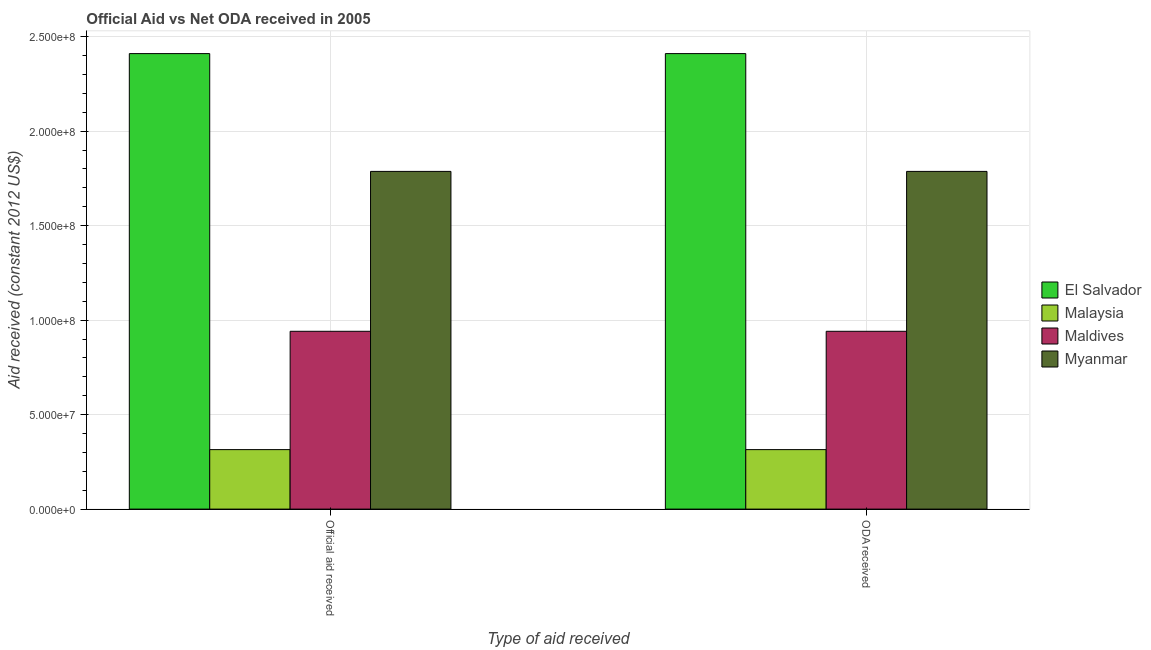How many different coloured bars are there?
Offer a terse response. 4. How many bars are there on the 2nd tick from the right?
Your response must be concise. 4. What is the label of the 1st group of bars from the left?
Make the answer very short. Official aid received. What is the official aid received in Malaysia?
Make the answer very short. 3.15e+07. Across all countries, what is the maximum oda received?
Your answer should be very brief. 2.41e+08. Across all countries, what is the minimum oda received?
Provide a short and direct response. 3.15e+07. In which country was the oda received maximum?
Ensure brevity in your answer.  El Salvador. In which country was the oda received minimum?
Your answer should be very brief. Malaysia. What is the total oda received in the graph?
Keep it short and to the point. 5.45e+08. What is the difference between the official aid received in Myanmar and that in Malaysia?
Offer a very short reply. 1.47e+08. What is the difference between the oda received in Maldives and the official aid received in El Salvador?
Offer a terse response. -1.47e+08. What is the average oda received per country?
Ensure brevity in your answer.  1.36e+08. What is the difference between the official aid received and oda received in Myanmar?
Ensure brevity in your answer.  0. What is the ratio of the oda received in Myanmar to that in Malaysia?
Provide a succinct answer. 5.68. Is the oda received in Maldives less than that in Myanmar?
Keep it short and to the point. Yes. In how many countries, is the official aid received greater than the average official aid received taken over all countries?
Provide a short and direct response. 2. What does the 3rd bar from the left in ODA received represents?
Make the answer very short. Maldives. What does the 1st bar from the right in Official aid received represents?
Make the answer very short. Myanmar. How many bars are there?
Your answer should be very brief. 8. How many legend labels are there?
Provide a succinct answer. 4. What is the title of the graph?
Make the answer very short. Official Aid vs Net ODA received in 2005 . What is the label or title of the X-axis?
Offer a terse response. Type of aid received. What is the label or title of the Y-axis?
Give a very brief answer. Aid received (constant 2012 US$). What is the Aid received (constant 2012 US$) in El Salvador in Official aid received?
Ensure brevity in your answer.  2.41e+08. What is the Aid received (constant 2012 US$) in Malaysia in Official aid received?
Ensure brevity in your answer.  3.15e+07. What is the Aid received (constant 2012 US$) of Maldives in Official aid received?
Keep it short and to the point. 9.41e+07. What is the Aid received (constant 2012 US$) in Myanmar in Official aid received?
Make the answer very short. 1.79e+08. What is the Aid received (constant 2012 US$) of El Salvador in ODA received?
Keep it short and to the point. 2.41e+08. What is the Aid received (constant 2012 US$) of Malaysia in ODA received?
Offer a very short reply. 3.15e+07. What is the Aid received (constant 2012 US$) in Maldives in ODA received?
Offer a terse response. 9.41e+07. What is the Aid received (constant 2012 US$) in Myanmar in ODA received?
Give a very brief answer. 1.79e+08. Across all Type of aid received, what is the maximum Aid received (constant 2012 US$) in El Salvador?
Your response must be concise. 2.41e+08. Across all Type of aid received, what is the maximum Aid received (constant 2012 US$) of Malaysia?
Your response must be concise. 3.15e+07. Across all Type of aid received, what is the maximum Aid received (constant 2012 US$) of Maldives?
Provide a succinct answer. 9.41e+07. Across all Type of aid received, what is the maximum Aid received (constant 2012 US$) in Myanmar?
Make the answer very short. 1.79e+08. Across all Type of aid received, what is the minimum Aid received (constant 2012 US$) in El Salvador?
Give a very brief answer. 2.41e+08. Across all Type of aid received, what is the minimum Aid received (constant 2012 US$) in Malaysia?
Your answer should be very brief. 3.15e+07. Across all Type of aid received, what is the minimum Aid received (constant 2012 US$) of Maldives?
Ensure brevity in your answer.  9.41e+07. Across all Type of aid received, what is the minimum Aid received (constant 2012 US$) in Myanmar?
Your answer should be very brief. 1.79e+08. What is the total Aid received (constant 2012 US$) of El Salvador in the graph?
Offer a terse response. 4.82e+08. What is the total Aid received (constant 2012 US$) in Malaysia in the graph?
Your answer should be compact. 6.30e+07. What is the total Aid received (constant 2012 US$) in Maldives in the graph?
Your answer should be compact. 1.88e+08. What is the total Aid received (constant 2012 US$) of Myanmar in the graph?
Make the answer very short. 3.57e+08. What is the difference between the Aid received (constant 2012 US$) in El Salvador in Official aid received and that in ODA received?
Make the answer very short. 0. What is the difference between the Aid received (constant 2012 US$) of Malaysia in Official aid received and that in ODA received?
Provide a succinct answer. 0. What is the difference between the Aid received (constant 2012 US$) in Myanmar in Official aid received and that in ODA received?
Your answer should be very brief. 0. What is the difference between the Aid received (constant 2012 US$) of El Salvador in Official aid received and the Aid received (constant 2012 US$) of Malaysia in ODA received?
Keep it short and to the point. 2.10e+08. What is the difference between the Aid received (constant 2012 US$) of El Salvador in Official aid received and the Aid received (constant 2012 US$) of Maldives in ODA received?
Your answer should be very brief. 1.47e+08. What is the difference between the Aid received (constant 2012 US$) in El Salvador in Official aid received and the Aid received (constant 2012 US$) in Myanmar in ODA received?
Provide a short and direct response. 6.23e+07. What is the difference between the Aid received (constant 2012 US$) in Malaysia in Official aid received and the Aid received (constant 2012 US$) in Maldives in ODA received?
Your answer should be compact. -6.26e+07. What is the difference between the Aid received (constant 2012 US$) in Malaysia in Official aid received and the Aid received (constant 2012 US$) in Myanmar in ODA received?
Make the answer very short. -1.47e+08. What is the difference between the Aid received (constant 2012 US$) of Maldives in Official aid received and the Aid received (constant 2012 US$) of Myanmar in ODA received?
Provide a succinct answer. -8.46e+07. What is the average Aid received (constant 2012 US$) of El Salvador per Type of aid received?
Offer a terse response. 2.41e+08. What is the average Aid received (constant 2012 US$) in Malaysia per Type of aid received?
Your answer should be very brief. 3.15e+07. What is the average Aid received (constant 2012 US$) in Maldives per Type of aid received?
Make the answer very short. 9.41e+07. What is the average Aid received (constant 2012 US$) of Myanmar per Type of aid received?
Keep it short and to the point. 1.79e+08. What is the difference between the Aid received (constant 2012 US$) in El Salvador and Aid received (constant 2012 US$) in Malaysia in Official aid received?
Ensure brevity in your answer.  2.10e+08. What is the difference between the Aid received (constant 2012 US$) in El Salvador and Aid received (constant 2012 US$) in Maldives in Official aid received?
Offer a terse response. 1.47e+08. What is the difference between the Aid received (constant 2012 US$) of El Salvador and Aid received (constant 2012 US$) of Myanmar in Official aid received?
Your response must be concise. 6.23e+07. What is the difference between the Aid received (constant 2012 US$) of Malaysia and Aid received (constant 2012 US$) of Maldives in Official aid received?
Provide a succinct answer. -6.26e+07. What is the difference between the Aid received (constant 2012 US$) in Malaysia and Aid received (constant 2012 US$) in Myanmar in Official aid received?
Give a very brief answer. -1.47e+08. What is the difference between the Aid received (constant 2012 US$) of Maldives and Aid received (constant 2012 US$) of Myanmar in Official aid received?
Give a very brief answer. -8.46e+07. What is the difference between the Aid received (constant 2012 US$) in El Salvador and Aid received (constant 2012 US$) in Malaysia in ODA received?
Keep it short and to the point. 2.10e+08. What is the difference between the Aid received (constant 2012 US$) in El Salvador and Aid received (constant 2012 US$) in Maldives in ODA received?
Your answer should be very brief. 1.47e+08. What is the difference between the Aid received (constant 2012 US$) of El Salvador and Aid received (constant 2012 US$) of Myanmar in ODA received?
Keep it short and to the point. 6.23e+07. What is the difference between the Aid received (constant 2012 US$) of Malaysia and Aid received (constant 2012 US$) of Maldives in ODA received?
Make the answer very short. -6.26e+07. What is the difference between the Aid received (constant 2012 US$) in Malaysia and Aid received (constant 2012 US$) in Myanmar in ODA received?
Your response must be concise. -1.47e+08. What is the difference between the Aid received (constant 2012 US$) in Maldives and Aid received (constant 2012 US$) in Myanmar in ODA received?
Provide a succinct answer. -8.46e+07. What is the ratio of the Aid received (constant 2012 US$) in El Salvador in Official aid received to that in ODA received?
Offer a terse response. 1. What is the ratio of the Aid received (constant 2012 US$) of Malaysia in Official aid received to that in ODA received?
Provide a short and direct response. 1. What is the ratio of the Aid received (constant 2012 US$) of Maldives in Official aid received to that in ODA received?
Give a very brief answer. 1. What is the ratio of the Aid received (constant 2012 US$) in Myanmar in Official aid received to that in ODA received?
Your answer should be very brief. 1. What is the difference between the highest and the second highest Aid received (constant 2012 US$) in Maldives?
Make the answer very short. 0. What is the difference between the highest and the second highest Aid received (constant 2012 US$) in Myanmar?
Your response must be concise. 0. What is the difference between the highest and the lowest Aid received (constant 2012 US$) of El Salvador?
Provide a succinct answer. 0. What is the difference between the highest and the lowest Aid received (constant 2012 US$) of Myanmar?
Your response must be concise. 0. 